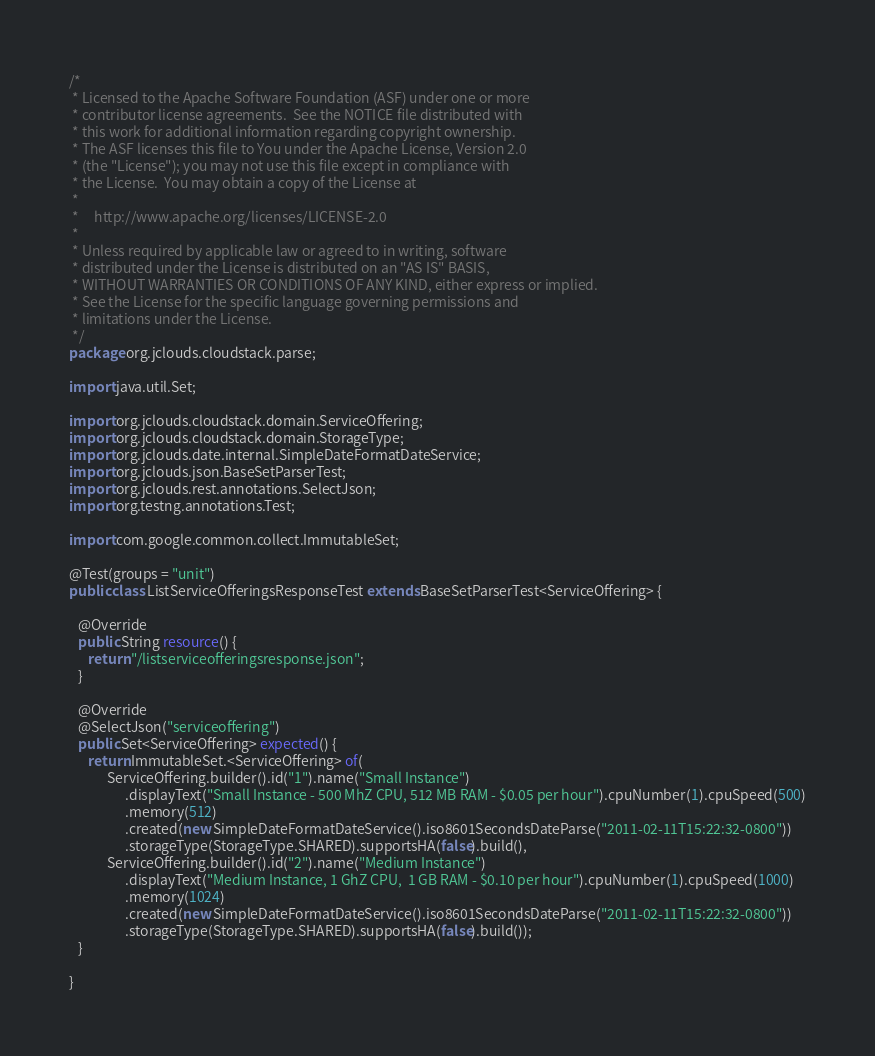<code> <loc_0><loc_0><loc_500><loc_500><_Java_>/*
 * Licensed to the Apache Software Foundation (ASF) under one or more
 * contributor license agreements.  See the NOTICE file distributed with
 * this work for additional information regarding copyright ownership.
 * The ASF licenses this file to You under the Apache License, Version 2.0
 * (the "License"); you may not use this file except in compliance with
 * the License.  You may obtain a copy of the License at
 *
 *     http://www.apache.org/licenses/LICENSE-2.0
 *
 * Unless required by applicable law or agreed to in writing, software
 * distributed under the License is distributed on an "AS IS" BASIS,
 * WITHOUT WARRANTIES OR CONDITIONS OF ANY KIND, either express or implied.
 * See the License for the specific language governing permissions and
 * limitations under the License.
 */
package org.jclouds.cloudstack.parse;

import java.util.Set;

import org.jclouds.cloudstack.domain.ServiceOffering;
import org.jclouds.cloudstack.domain.StorageType;
import org.jclouds.date.internal.SimpleDateFormatDateService;
import org.jclouds.json.BaseSetParserTest;
import org.jclouds.rest.annotations.SelectJson;
import org.testng.annotations.Test;

import com.google.common.collect.ImmutableSet;

@Test(groups = "unit")
public class ListServiceOfferingsResponseTest extends BaseSetParserTest<ServiceOffering> {

   @Override
   public String resource() {
      return "/listserviceofferingsresponse.json";
   }

   @Override
   @SelectJson("serviceoffering")
   public Set<ServiceOffering> expected() {
      return ImmutableSet.<ServiceOffering> of(
            ServiceOffering.builder().id("1").name("Small Instance")
                  .displayText("Small Instance - 500 MhZ CPU, 512 MB RAM - $0.05 per hour").cpuNumber(1).cpuSpeed(500)
                  .memory(512)
                  .created(new SimpleDateFormatDateService().iso8601SecondsDateParse("2011-02-11T15:22:32-0800"))
                  .storageType(StorageType.SHARED).supportsHA(false).build(),
            ServiceOffering.builder().id("2").name("Medium Instance")
                  .displayText("Medium Instance, 1 GhZ CPU,  1 GB RAM - $0.10 per hour").cpuNumber(1).cpuSpeed(1000)
                  .memory(1024)
                  .created(new SimpleDateFormatDateService().iso8601SecondsDateParse("2011-02-11T15:22:32-0800"))
                  .storageType(StorageType.SHARED).supportsHA(false).build());
   }

}
</code> 